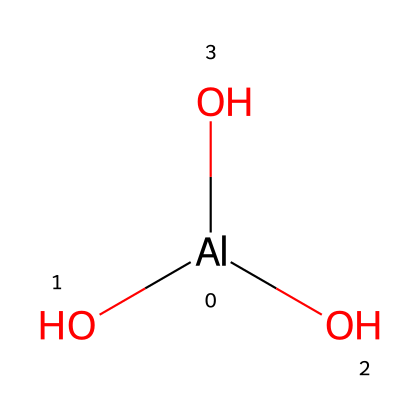What is the central atom in this chemical structure? The SMILES representation indicates that aluminum is the central atom because it is represented by the symbol [Al], which is placed at the beginning of the structure.
Answer: aluminum How many hydroxyl groups are present in the chemical structure? The structure has three oxygen atoms, each connected to a hydrogen atom through single bonds, indicating the presence of three hydroxyl groups (-OH). This observation is corroborated by the three instances of "O" in the SMILES notation.
Answer: three What type of bond connects the aluminum atom to the hydroxyl groups? The bonds connecting aluminum to the hydroxyl groups are covalent bonds, as evidenced by the structure showing shared pairs of electrons between the aluminum and oxygen atoms.
Answer: covalent Is the chemical compound likely to be soluble in water? Compounds with hydroxyl groups typically exhibit higher solubility in water due to hydrogen bonding, which suggests that this compound should dissolve in water.
Answer: yes What is the oxidation state of aluminum in this structure? In this chemical structure, aluminum is in the +3 oxidation state, which can be inferred from its tetravalent coordination with three hydroxyl groups and the tendency of aluminum to lose three electrons.
Answer: +3 Does this chemical structure represent an inorganic or organic compound? Given that aluminum and hydroxyl groups characterize this compound without any carbon atoms, it is classified as an inorganic compound.
Answer: inorganic 